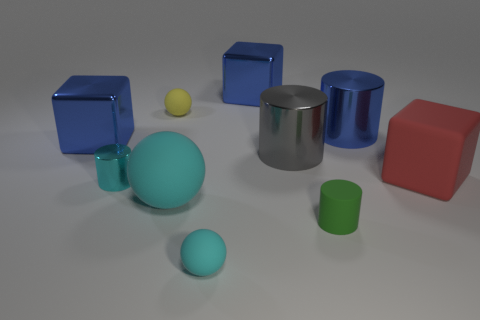The matte cylinder in front of the shiny cube behind the tiny matte thing behind the big blue shiny cylinder is what color? green 